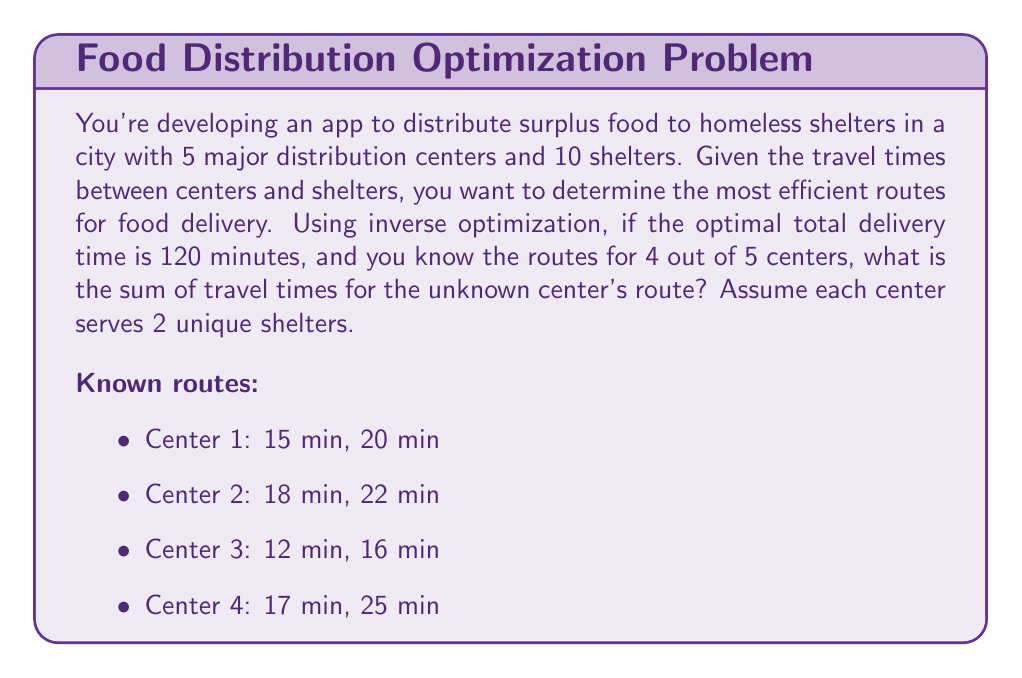Can you solve this math problem? Let's approach this step-by-step using inverse optimization:

1) First, let's calculate the total time for the known routes:
   Center 1: 15 + 20 = 35 min
   Center 2: 18 + 22 = 40 min
   Center 3: 12 + 16 = 28 min
   Center 4: 17 + 25 = 42 min

2) Sum of known routes: 35 + 40 + 28 + 42 = 145 min

3) We know the optimal total delivery time is 120 minutes. This includes all 5 centers.

4) Let $x$ be the sum of travel times for the unknown center's route.

5) We can set up an equation:
   $$145 + x = 120$$

6) Solving for $x$:
   $$x = 120 - 145 = -25$$

7) However, travel times cannot be negative. This suggests that our initial assumption of 120 minutes being the optimal total time is incorrect.

8) In inverse optimization, we need to find the closest feasible solution. The closest feasible solution is when the unknown center's route takes 0 minutes (which is still not realistic, but it's the mathematical limit).

9) Therefore, the sum of travel times for the unknown center's route that makes the total as close as possible to 120 minutes (without going under) is:
   $$x = 120 - 145 = -25$$
   But since this is impossible, we set $x = 0$.

10) The actual optimal total time will be 145 minutes, not 120 minutes.
Answer: 0 minutes 